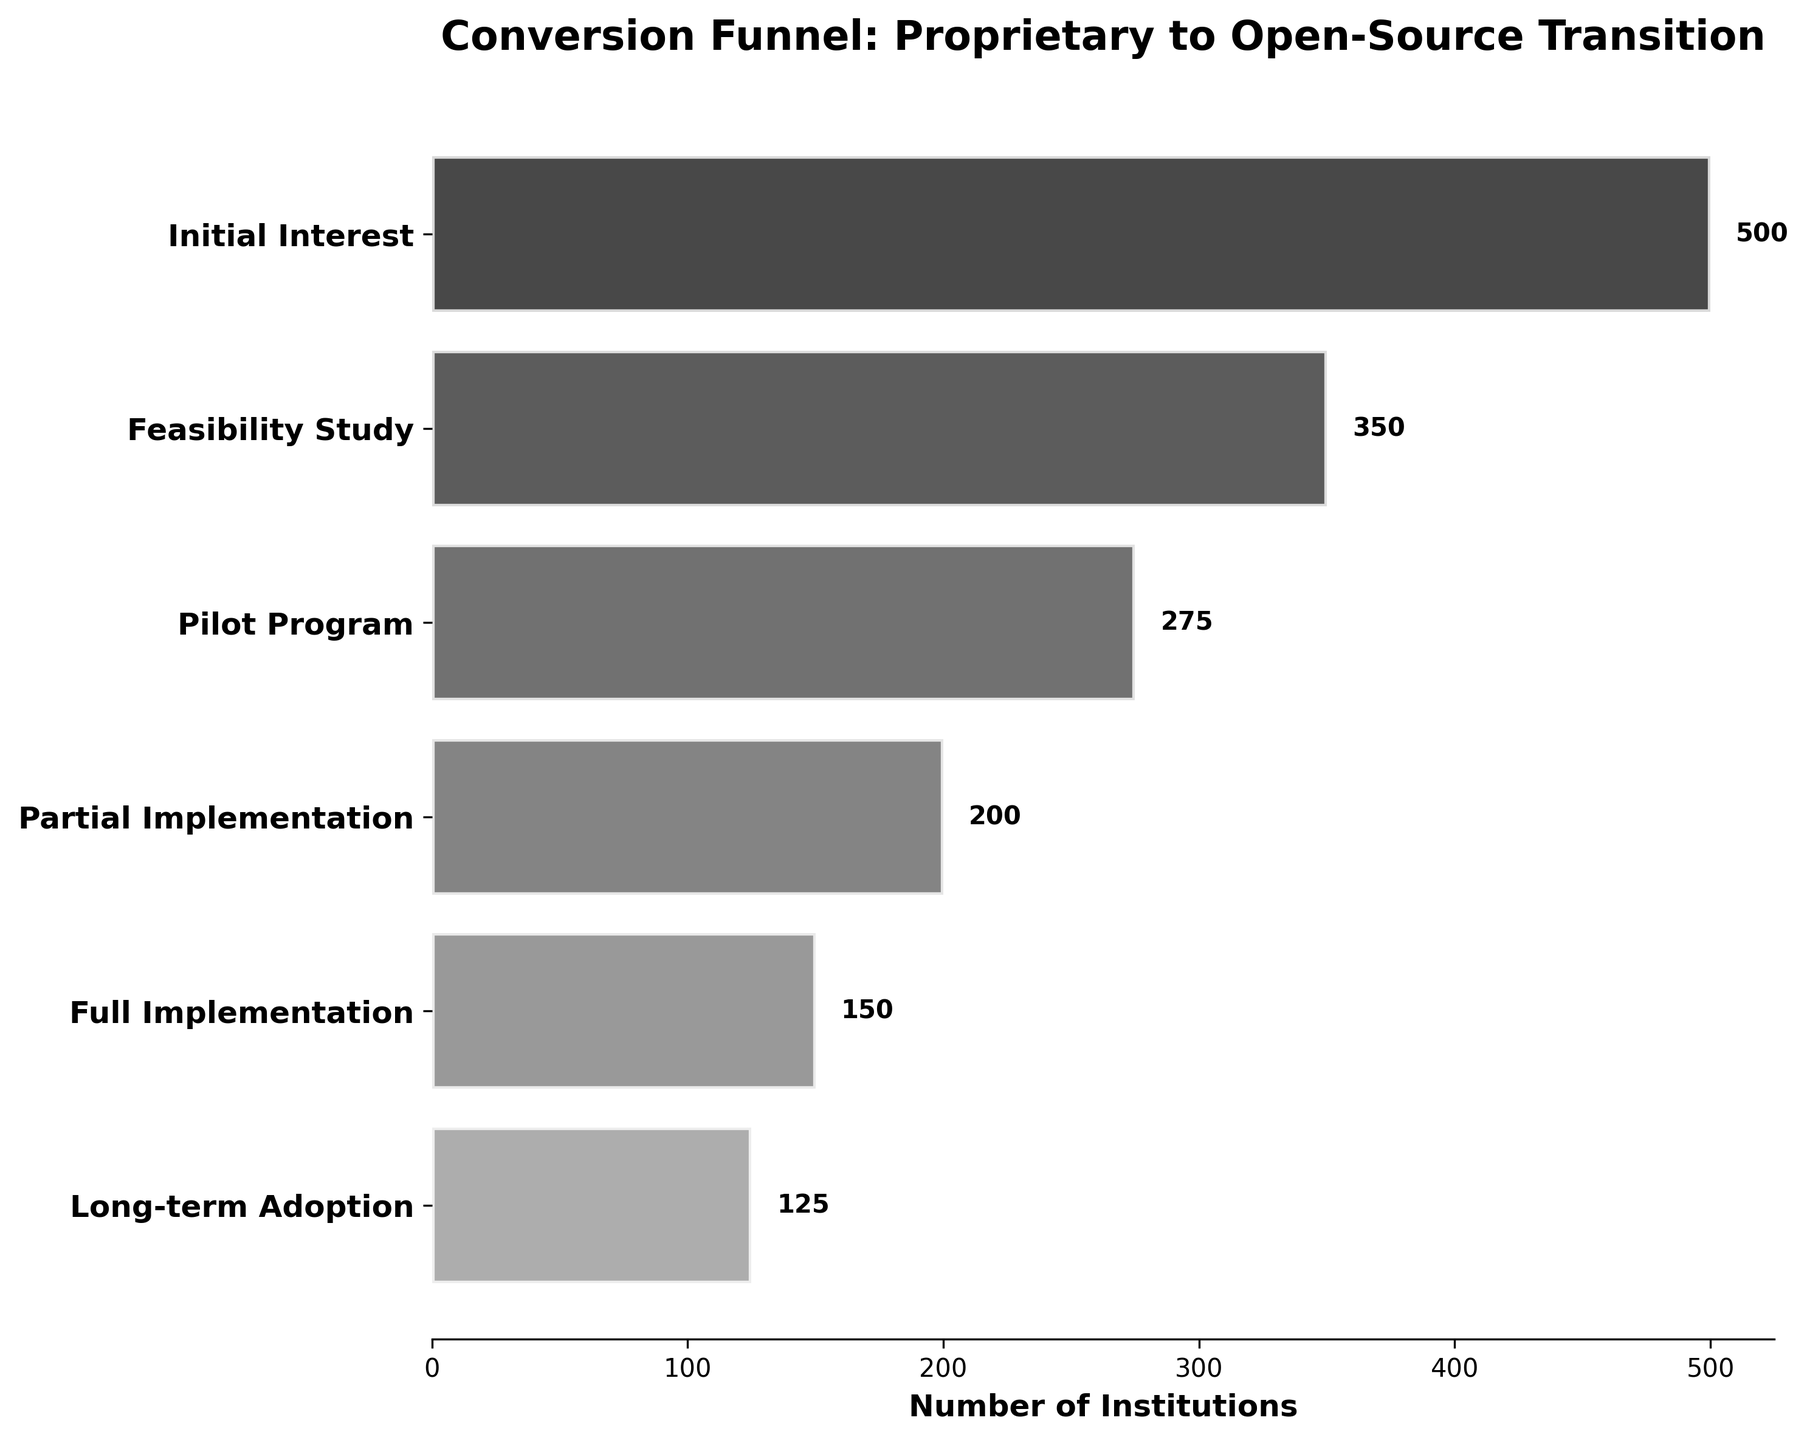What is the title of the funnel chart? The title is displayed at the top of the chart. It provides an overview or summary of what the chart is depicting.
Answer: Conversion Funnel: Proprietary to Open-Source Transition Which stage has the highest number of institutions? To determine which stage has the highest number of institutions, look for the widest bar in the funnel chart.
Answer: Initial Interest How many institutions reached the Full Implementation stage? By examining the bars, find the one labeled 'Full Implementation' and check the number at the end of the bar.
Answer: 150 What is the difference in the number of institutions between the Feasibility Study and Pilot Program stages? Subtract the number of institutions in the Pilot Program stage from the number in the Feasibility Study stage.
Answer: 75 Is the number of institutions that went from Pilot Program to Partial Implementation more or less than those that went from Full Implementation to Long-term Adoption? Compare the difference in institution numbers between the Pilot to Partial stages and Full to Long-term stages by subtracting the institution numbers accordingly.
Answer: More What is the total number of institutions that made it to the Pilot Program? Locate the label 'Pilot Program' and note the number next to the bar.
Answer: 275 What percentage of institutions move from Initial Interest to Long-term Adoption? To find this percentage, divide the number of institutions in the Long-term Adoption stage by the number in the Initial Interest stage, and multiply by 100.
Answer: 25% How many institutions drop off between the Feasibility Study and Long-term Adoption stages? Subtract the number of institutions in the Long-term Adoption stage from the number in the Feasibility Study stage.
Answer: 225 Which stage represents the smallest drop-off in the number of institutions? Analyze the differences between adjacent stages to find the smallest drop-off.
Answer: Full Implementation to Long-term Adoption Are there more institutions involved in the Feasibility Study stage or in the Partial Implementation stage? Compare the number of institutions in the Feasibility Study stage with those in the Partial Implementation stage.
Answer: Feasibility Study 